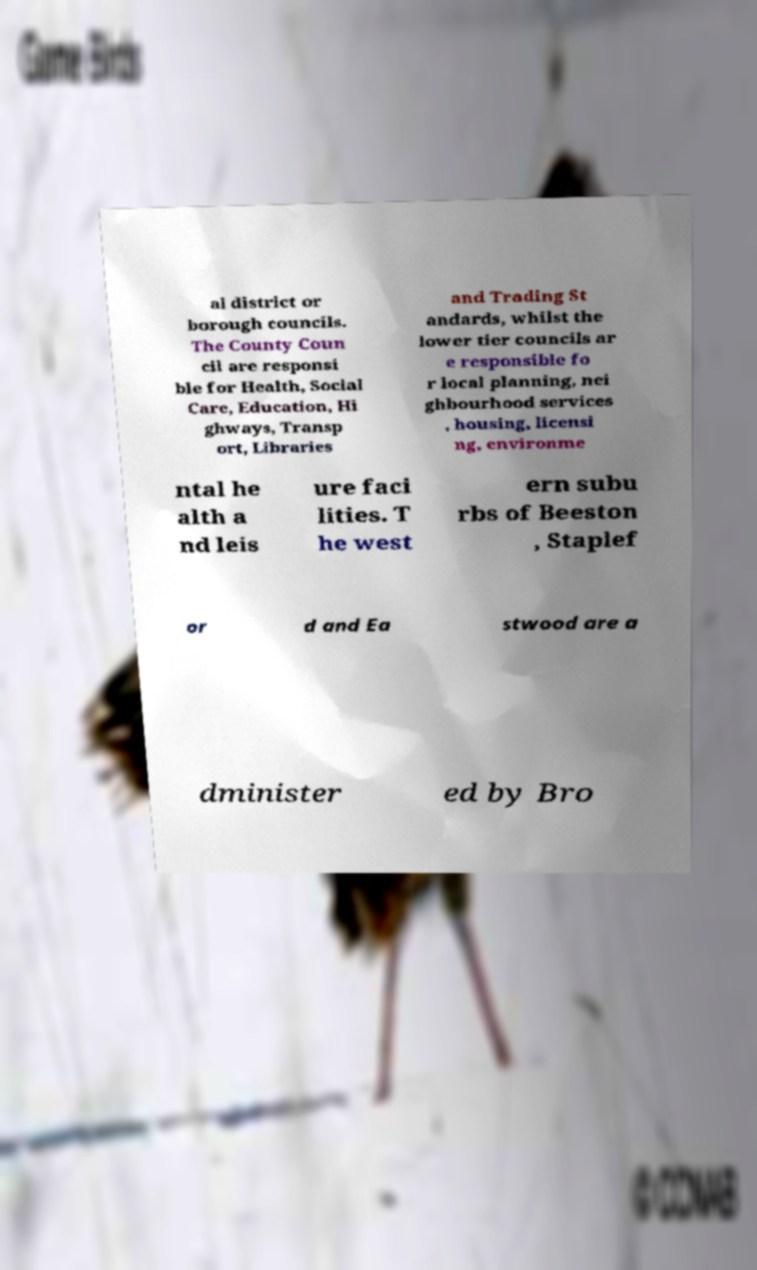Please read and relay the text visible in this image. What does it say? al district or borough councils. The County Coun cil are responsi ble for Health, Social Care, Education, Hi ghways, Transp ort, Libraries and Trading St andards, whilst the lower tier councils ar e responsible fo r local planning, nei ghbourhood services , housing, licensi ng, environme ntal he alth a nd leis ure faci lities. T he west ern subu rbs of Beeston , Staplef or d and Ea stwood are a dminister ed by Bro 